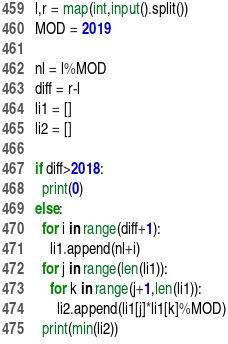<code> <loc_0><loc_0><loc_500><loc_500><_Python_>l,r = map(int,input().split())
MOD = 2019

nl = l%MOD
diff = r-l
li1 = []
li2 = []

if diff>2018:
  print(0)
else:
  for i in range(diff+1):
    li1.append(nl+i)
  for j in range(len(li1)):
    for k in range(j+1,len(li1)):
      li2.append(li1[j]*li1[k]%MOD)
  print(min(li2))</code> 